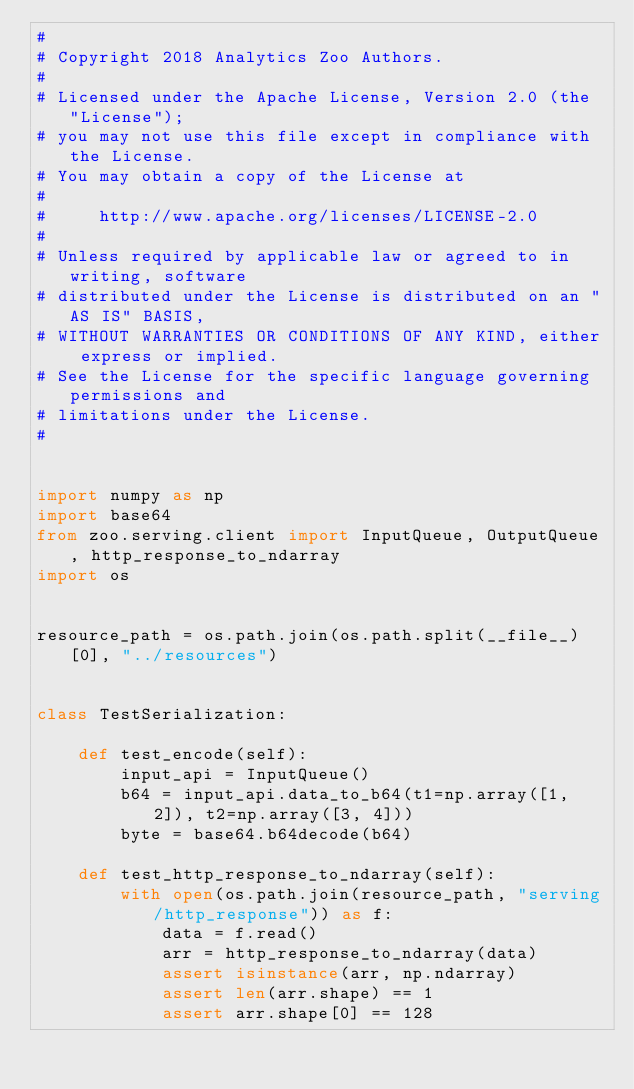Convert code to text. <code><loc_0><loc_0><loc_500><loc_500><_Python_>#
# Copyright 2018 Analytics Zoo Authors.
#
# Licensed under the Apache License, Version 2.0 (the "License");
# you may not use this file except in compliance with the License.
# You may obtain a copy of the License at
#
#     http://www.apache.org/licenses/LICENSE-2.0
#
# Unless required by applicable law or agreed to in writing, software
# distributed under the License is distributed on an "AS IS" BASIS,
# WITHOUT WARRANTIES OR CONDITIONS OF ANY KIND, either express or implied.
# See the License for the specific language governing permissions and
# limitations under the License.
#


import numpy as np
import base64
from zoo.serving.client import InputQueue, OutputQueue, http_response_to_ndarray
import os


resource_path = os.path.join(os.path.split(__file__)[0], "../resources")


class TestSerialization:

    def test_encode(self):
        input_api = InputQueue()
        b64 = input_api.data_to_b64(t1=np.array([1, 2]), t2=np.array([3, 4]))
        byte = base64.b64decode(b64)

    def test_http_response_to_ndarray(self):
        with open(os.path.join(resource_path, "serving/http_response")) as f:
            data = f.read()
            arr = http_response_to_ndarray(data)
            assert isinstance(arr, np.ndarray)
            assert len(arr.shape) == 1
            assert arr.shape[0] == 128
</code> 